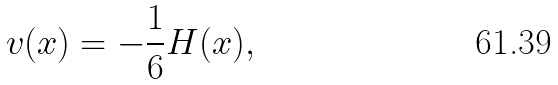Convert formula to latex. <formula><loc_0><loc_0><loc_500><loc_500>v ( x ) = - \frac { 1 } { 6 } H ( x ) ,</formula> 